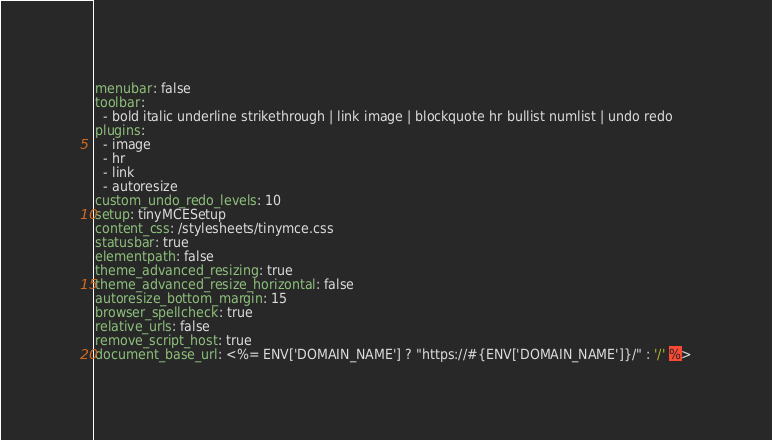<code> <loc_0><loc_0><loc_500><loc_500><_YAML_>menubar: false
toolbar:
  - bold italic underline strikethrough | link image | blockquote hr bullist numlist | undo redo
plugins:
  - image
  - hr
  - link
  - autoresize
custom_undo_redo_levels: 10
setup: tinyMCESetup
content_css: /stylesheets/tinymce.css
statusbar: true
elementpath: false
theme_advanced_resizing: true
theme_advanced_resize_horizontal: false
autoresize_bottom_margin: 15
browser_spellcheck: true
relative_urls: false
remove_script_host: true
document_base_url: <%= ENV['DOMAIN_NAME'] ? "https://#{ENV['DOMAIN_NAME']}/" : '/' %>
</code> 